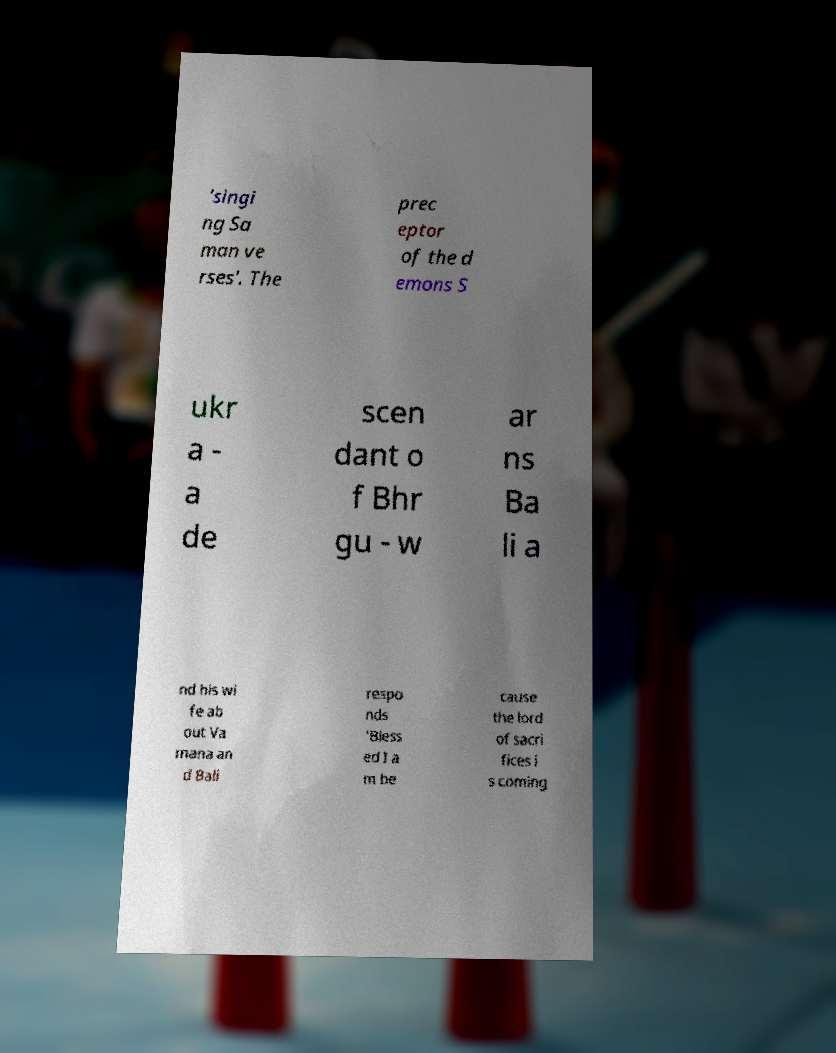Please identify and transcribe the text found in this image. 'singi ng Sa man ve rses'. The prec eptor of the d emons S ukr a - a de scen dant o f Bhr gu - w ar ns Ba li a nd his wi fe ab out Va mana an d Bali respo nds 'Bless ed I a m be cause the lord of sacri fices i s coming 